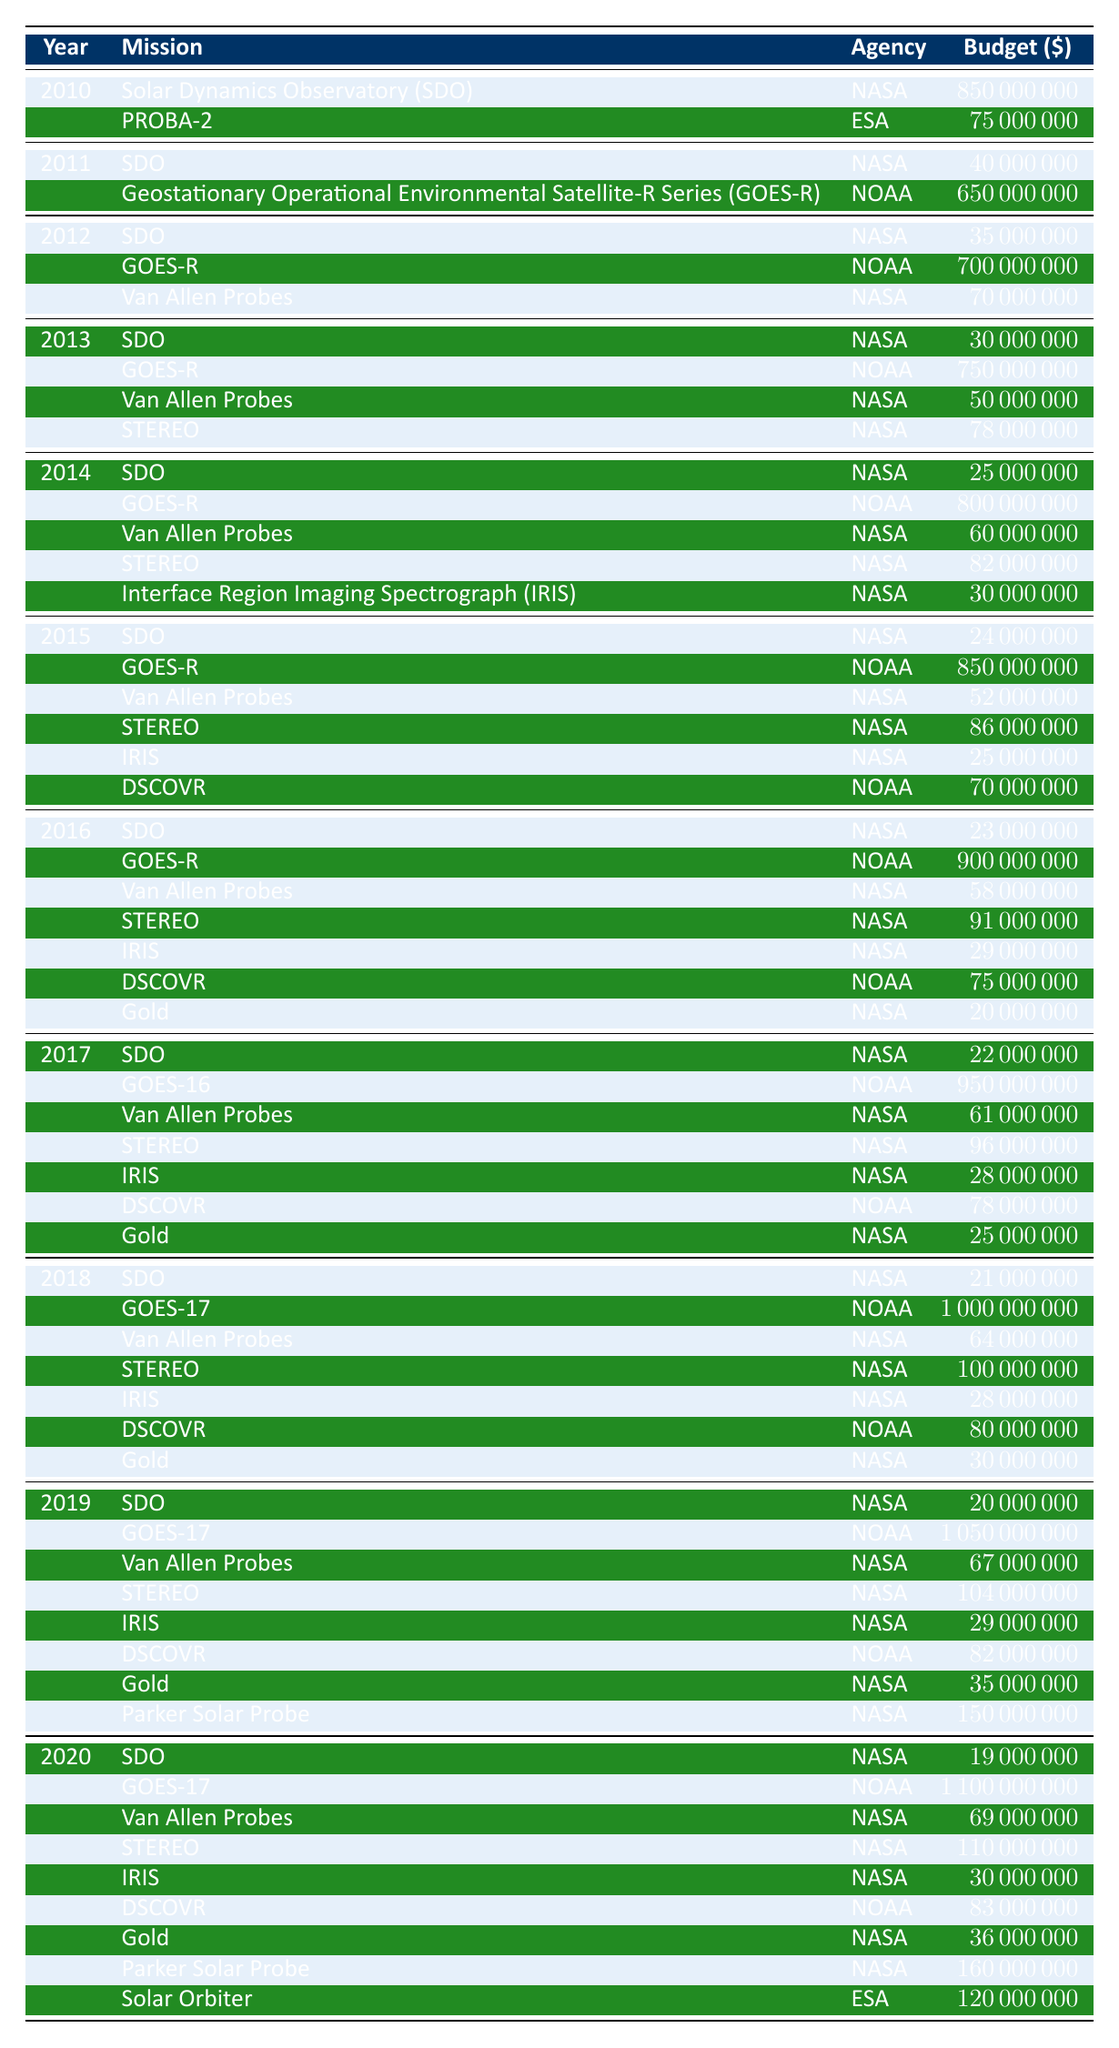What was the total budget for the Solar Dynamics Observatory (SDO) from 2010 to 2020? The budget for SDO across the years is as follows: 850 million in 2010, 40 million in 2011, 35 million in 2012, 30 million in 2013, 25 million in 2014, 24 million in 2015, 23 million in 2016, 22 million in 2017, 21 million in 2018, 20 million in 2019, and 19 million in 2020. Summing these values (850 + 40 + 35 + 30 + 25 + 24 + 23 + 22 + 21 + 20 + 19) results in 1,089 million.
Answer: 1,089 million How much did NOAA allocate for the GOES-R series in 2015? The budget for GOES-R in 2015 is listed as 850 million in the table.
Answer: 850 million Was the total budget for the Van Allen Probes higher than that for the STEREO mission over the same period? The budgets for Van Allen Probes were: 70 million (2012), 50 million (2013), 60 million (2014), 52 million (2015), 58 million (2016), 61 million (2017), 64 million (2018), 67 million (2019), and 69 million (2020), totaling 429 million. For STEREO, the budgets were: 78 million (2013), 82 million (2014), 86 million (2015), 91 million (2016), 96 million (2017), 100 million (2018), 104 million (2019), and 110 million (2020), totaling 637 million. Since 429 million < 637 million, the statement is false.
Answer: No Which year had the highest budget allocated to NOAA for space weather missions and what was the amount? The year with the highest budget for NOAA is 2020, with a budget for GOES-17 of 1,100 million.
Answer: 1,100 million in 2020 What is the average budget for NASA missions over the whole period from 2010 to 2020? To find the average budget for NASA missions, we first sum all NASA budgets from the table: 850 + 40 + 35 + 30 + 25 + 24 + 23 + 22 + 21 + 20 + 19 + 70 + 50 + 60 + 52 + 58 + 61 + 64 + 67 + 69 + 150 + 160 + 20 = 1,509 million. There are 24 entries, thus the average is 1,509 million / 24 = 62.875 million.
Answer: 62.875 million Was there any year during this period where the total budget for NOAA missions exceeded that of NASA missions? To analyze each year, we compare total budgets for both agencies. NOAA had budgets for GOES-R ranging from 650 million to 1,100 million across the years, while NASA’s highest budget was 850 million in 2010. In 2011, NOAA had 650 million compared to NASA's 40 million. Thus, for 2011, NOAA’s budget exceeded NASA’s, confirming that yes, there were years when NOAA’s budget exceeded NASA’s.
Answer: Yes 